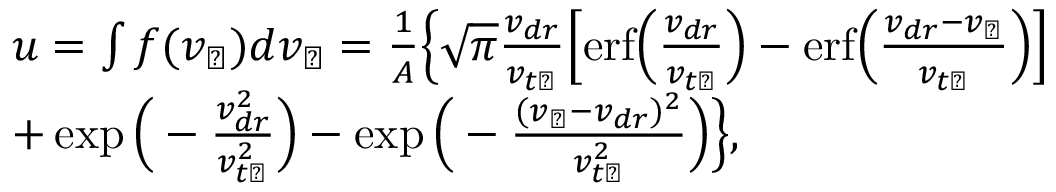Convert formula to latex. <formula><loc_0><loc_0><loc_500><loc_500>\begin{array} { r l } & { u = \int f ( v _ { \perp } ) d v _ { \perp } = \frac { 1 } { A } \left \{ \sqrt { \pi } \frac { v _ { d r } } { v _ { t \perp } } \left [ e r f \left ( \frac { v _ { d r } } { v _ { t \perp } } \right ) - e r f \left ( \frac { v _ { d r } - v _ { \perp } } { v _ { t \perp } } \right ) \right ] } \\ & { + \exp \left ( - \frac { v _ { d r } ^ { 2 } } { v _ { t \perp } ^ { 2 } } \right ) - \exp \left ( - \frac { ( v _ { \perp } - v _ { d r } ) ^ { 2 } } { v _ { t \perp } ^ { 2 } } \right ) \right \} , } \end{array}</formula> 